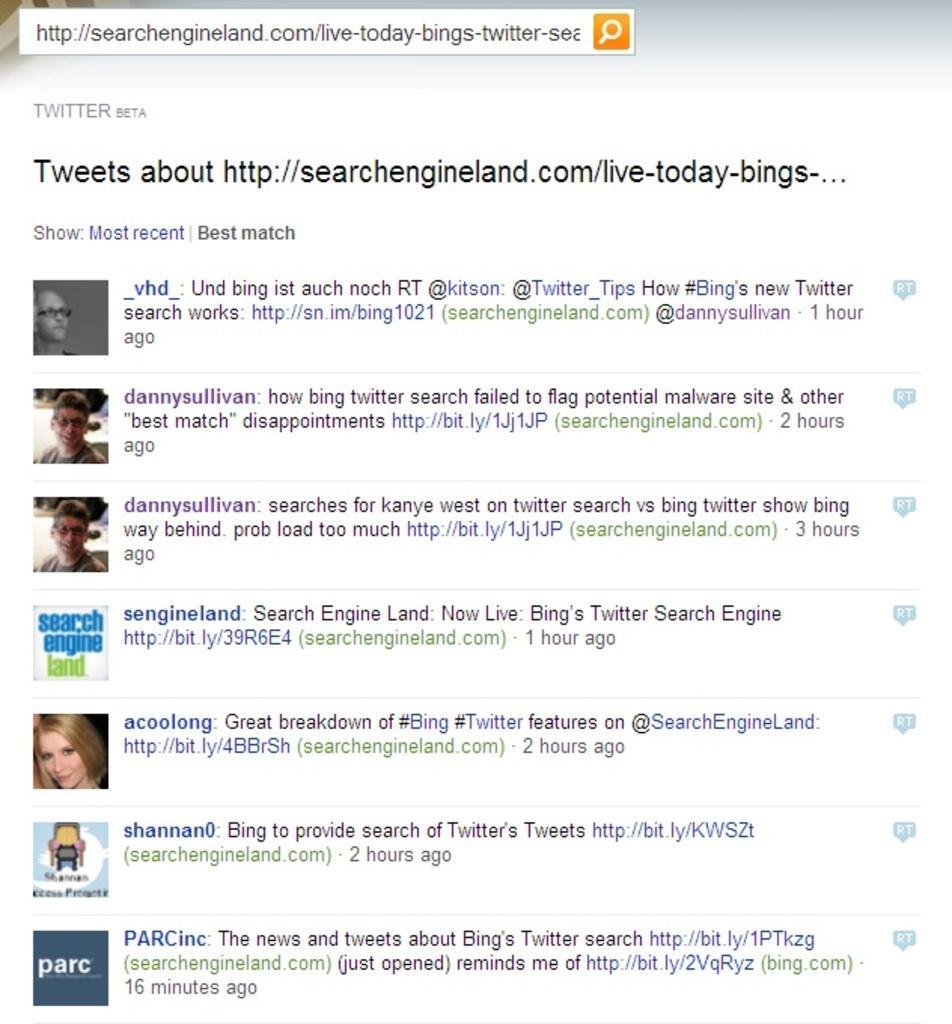Could you give a brief overview of what you see in this image? In this image there is a screen shot of the tweets one after the other. There are so many tweets in this image. 